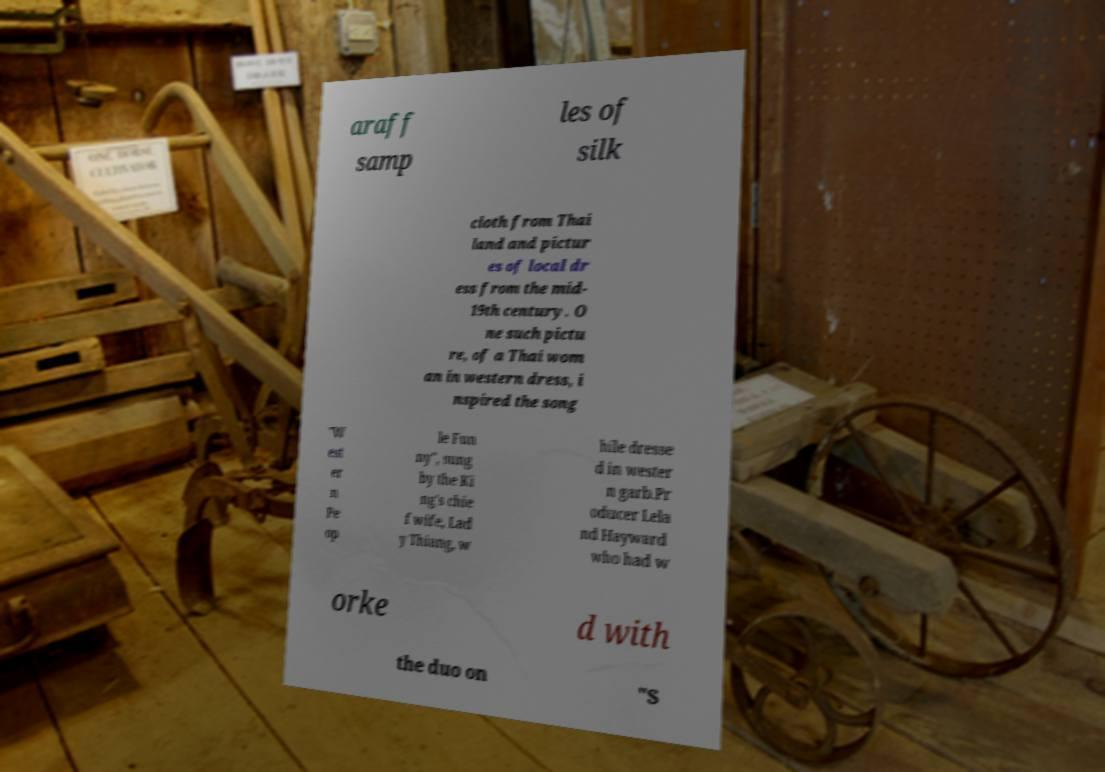Could you assist in decoding the text presented in this image and type it out clearly? araff samp les of silk cloth from Thai land and pictur es of local dr ess from the mid- 19th century. O ne such pictu re, of a Thai wom an in western dress, i nspired the song "W est er n Pe op le Fun ny", sung by the Ki ng's chie f wife, Lad y Thiang, w hile dresse d in wester n garb.Pr oducer Lela nd Hayward who had w orke d with the duo on "S 